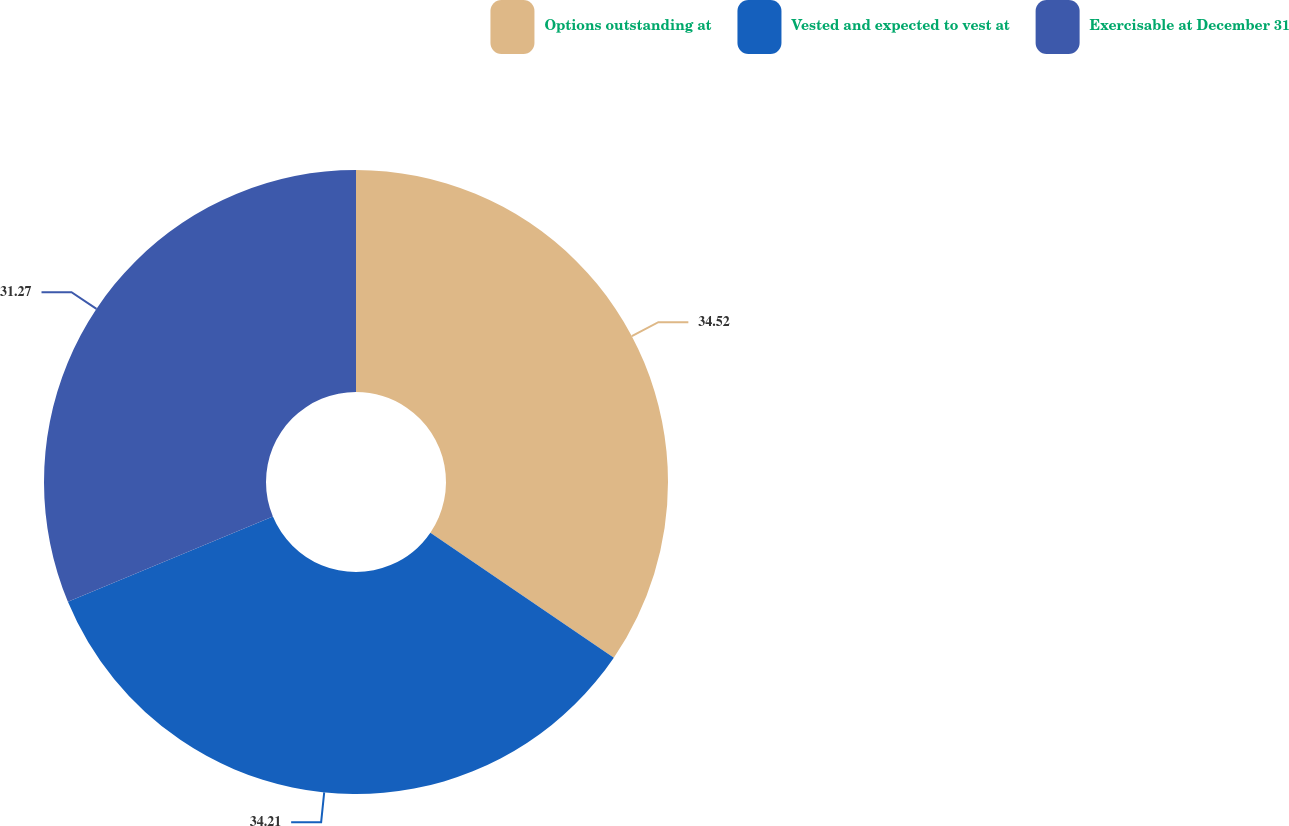<chart> <loc_0><loc_0><loc_500><loc_500><pie_chart><fcel>Options outstanding at<fcel>Vested and expected to vest at<fcel>Exercisable at December 31<nl><fcel>34.52%<fcel>34.21%<fcel>31.27%<nl></chart> 